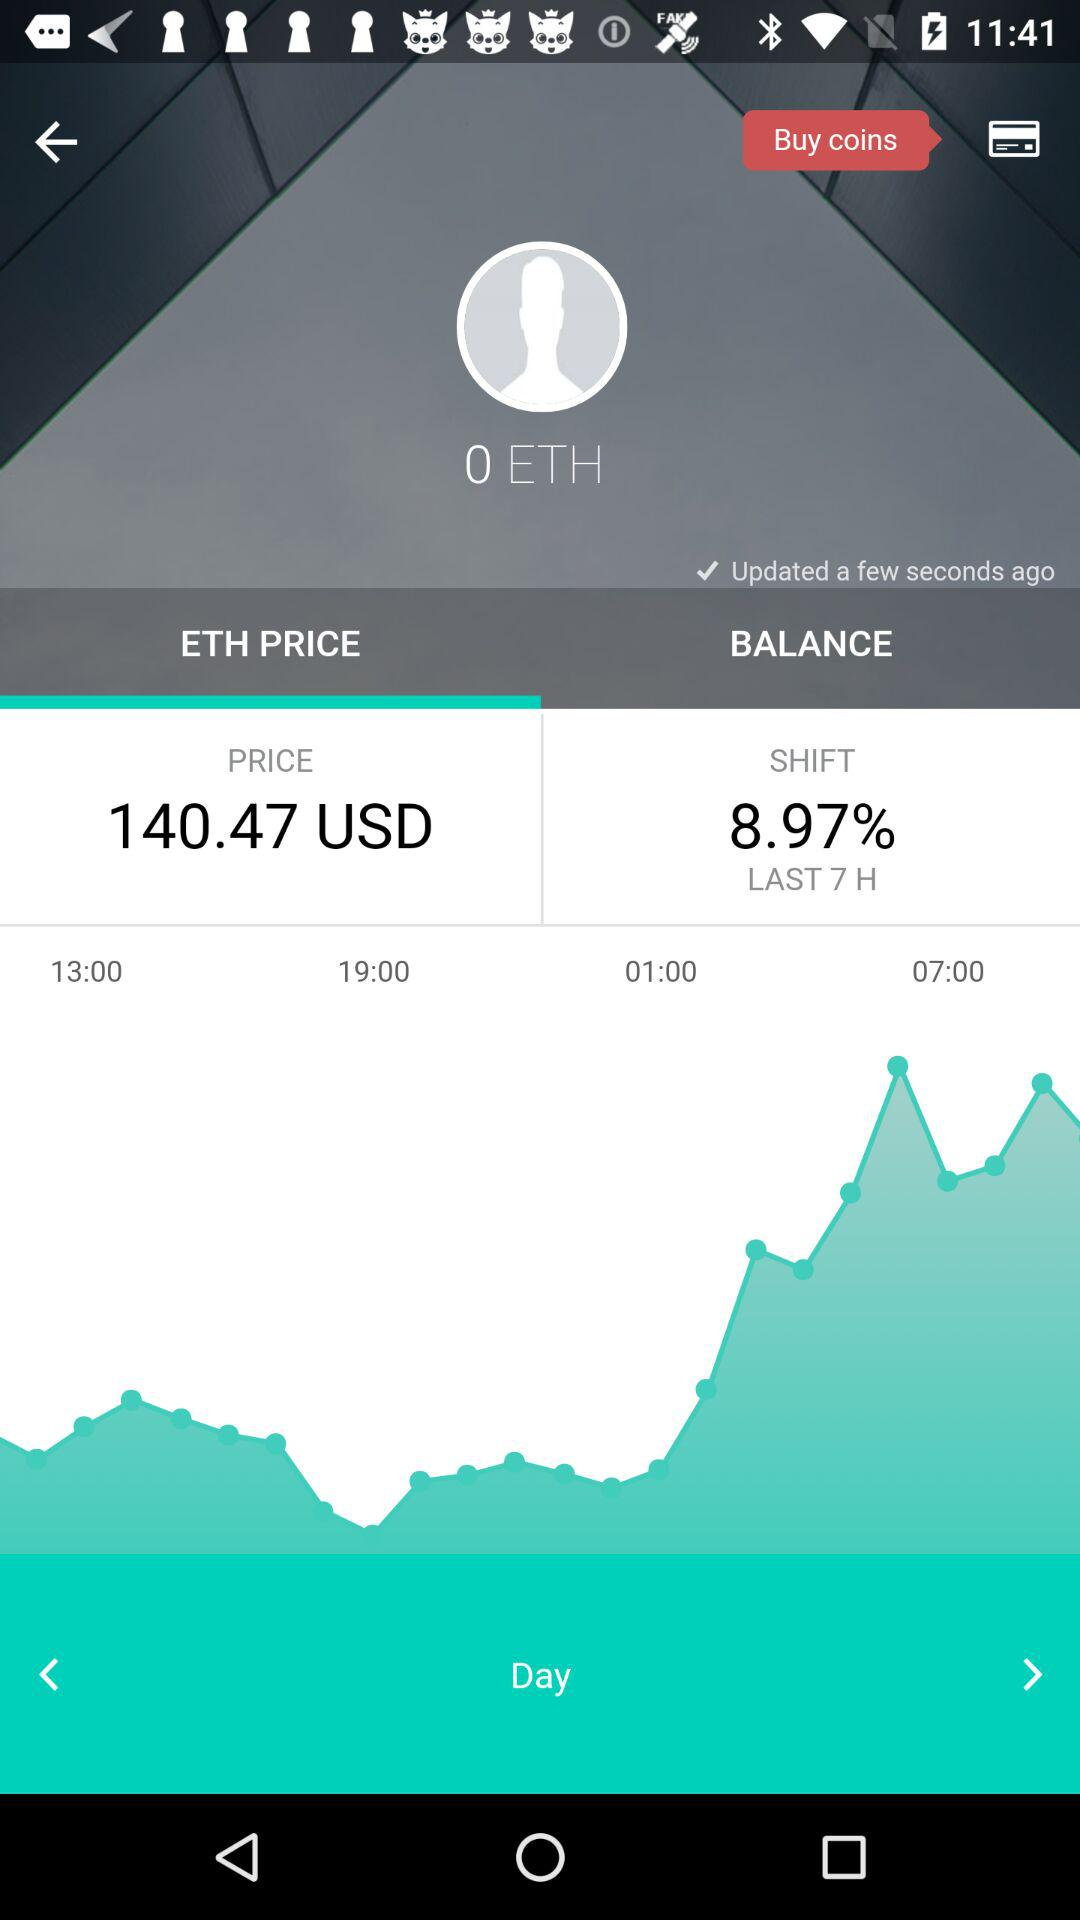How much is the ETH price? The ETH price is 140.47 USD. 